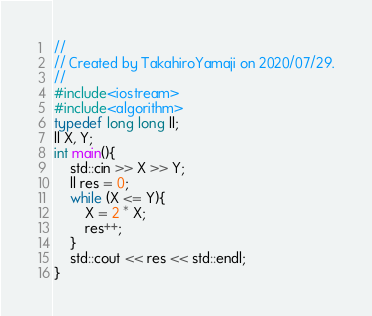<code> <loc_0><loc_0><loc_500><loc_500><_C++_>//
// Created by TakahiroYamaji on 2020/07/29.
//
#include<iostream>
#include<algorithm>
typedef long long ll;
ll X, Y;
int main(){
    std::cin >> X >> Y;
    ll res = 0;
    while (X <= Y){
        X = 2 * X;
        res++;
    }
    std::cout << res << std::endl;
}

</code> 